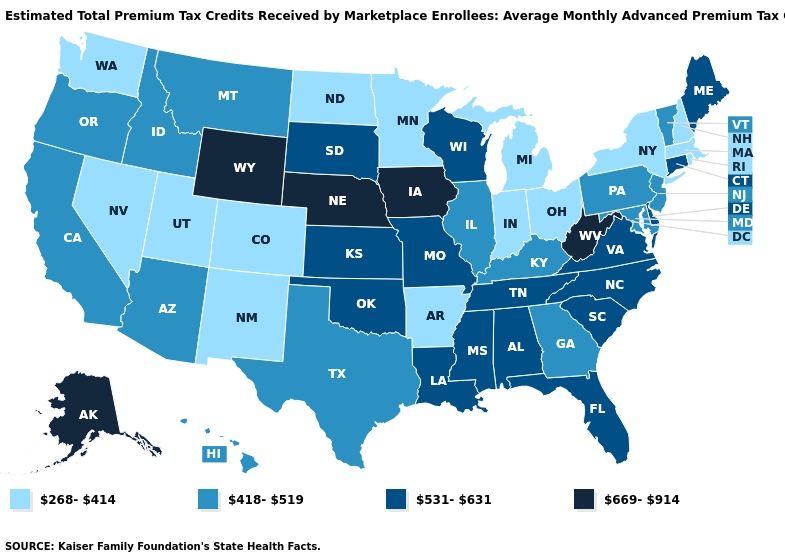What is the lowest value in the West?
Answer briefly. 268-414. Name the states that have a value in the range 268-414?
Keep it brief. Arkansas, Colorado, Indiana, Massachusetts, Michigan, Minnesota, Nevada, New Hampshire, New Mexico, New York, North Dakota, Ohio, Rhode Island, Utah, Washington. Does Kentucky have the same value as Hawaii?
Be succinct. Yes. What is the value of Indiana?
Be succinct. 268-414. Does the first symbol in the legend represent the smallest category?
Short answer required. Yes. What is the lowest value in the West?
Write a very short answer. 268-414. What is the value of Kansas?
Concise answer only. 531-631. What is the lowest value in the USA?
Concise answer only. 268-414. Among the states that border Maine , which have the highest value?
Short answer required. New Hampshire. Which states hav the highest value in the MidWest?
Be succinct. Iowa, Nebraska. What is the highest value in the MidWest ?
Answer briefly. 669-914. What is the lowest value in the West?
Concise answer only. 268-414. What is the highest value in states that border New Mexico?
Give a very brief answer. 531-631. Does South Dakota have the same value as Hawaii?
Short answer required. No. Which states have the highest value in the USA?
Short answer required. Alaska, Iowa, Nebraska, West Virginia, Wyoming. 